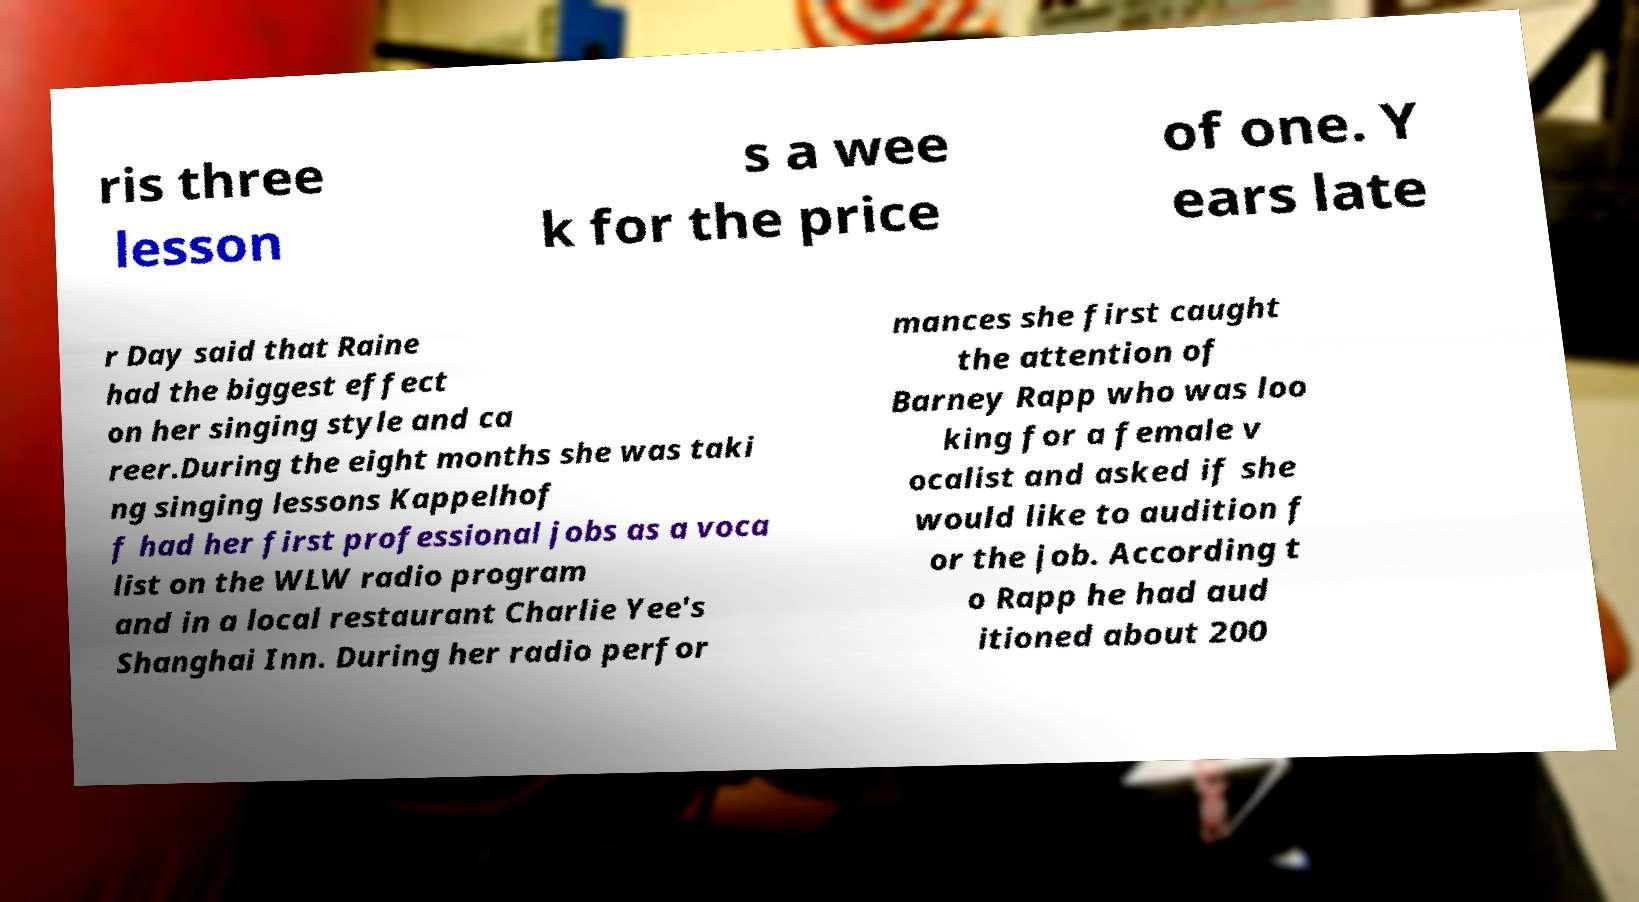Can you read and provide the text displayed in the image?This photo seems to have some interesting text. Can you extract and type it out for me? ris three lesson s a wee k for the price of one. Y ears late r Day said that Raine had the biggest effect on her singing style and ca reer.During the eight months she was taki ng singing lessons Kappelhof f had her first professional jobs as a voca list on the WLW radio program and in a local restaurant Charlie Yee's Shanghai Inn. During her radio perfor mances she first caught the attention of Barney Rapp who was loo king for a female v ocalist and asked if she would like to audition f or the job. According t o Rapp he had aud itioned about 200 